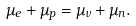<formula> <loc_0><loc_0><loc_500><loc_500>\mu _ { e } + \mu _ { p } = \mu _ { \nu } + \mu _ { n } .</formula> 